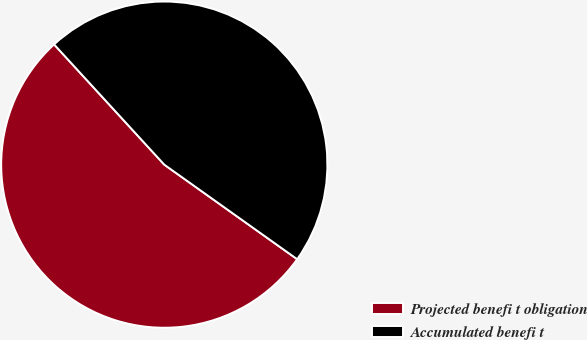<chart> <loc_0><loc_0><loc_500><loc_500><pie_chart><fcel>Projected benefi t obligation<fcel>Accumulated benefi t<nl><fcel>53.35%<fcel>46.65%<nl></chart> 